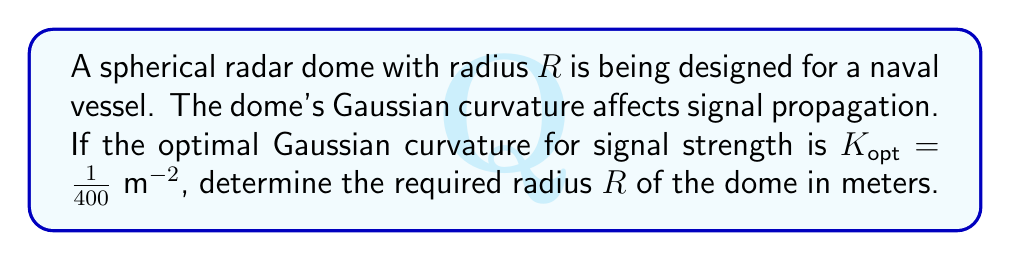Teach me how to tackle this problem. To solve this problem, we'll follow these steps:

1) Recall that for a sphere, the Gaussian curvature $K$ is constant and given by:

   $$K = \frac{1}{R^2}$$

   where $R$ is the radius of the sphere.

2) We're given that the optimal Gaussian curvature $K_{opt} = \frac{1}{400} \text{ m}^{-2}$

3) Set up the equation:

   $$K_{opt} = \frac{1}{R^2}$$

4) Substitute the given value:

   $$\frac{1}{400} = \frac{1}{R^2}$$

5) Solve for $R$:
   
   $$R^2 = 400$$
   
   $$R = \sqrt{400} = 20$$

Therefore, the required radius of the radar dome is 20 meters.
Answer: $R = 20 \text{ m}$ 